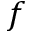<formula> <loc_0><loc_0><loc_500><loc_500>f</formula> 